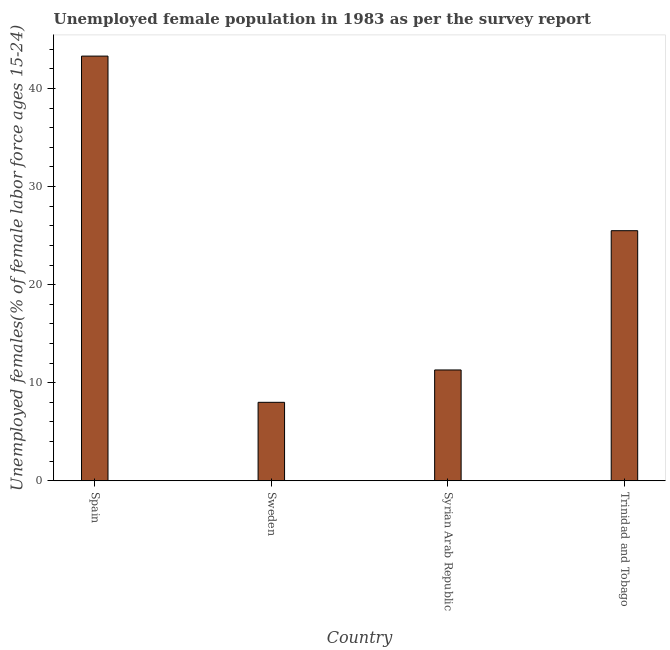What is the title of the graph?
Offer a very short reply. Unemployed female population in 1983 as per the survey report. What is the label or title of the X-axis?
Your answer should be compact. Country. What is the label or title of the Y-axis?
Keep it short and to the point. Unemployed females(% of female labor force ages 15-24). Across all countries, what is the maximum unemployed female youth?
Your answer should be very brief. 43.3. Across all countries, what is the minimum unemployed female youth?
Ensure brevity in your answer.  8. In which country was the unemployed female youth minimum?
Ensure brevity in your answer.  Sweden. What is the sum of the unemployed female youth?
Offer a terse response. 88.1. What is the difference between the unemployed female youth in Syrian Arab Republic and Trinidad and Tobago?
Offer a very short reply. -14.2. What is the average unemployed female youth per country?
Your answer should be very brief. 22.02. What is the median unemployed female youth?
Your response must be concise. 18.4. What is the ratio of the unemployed female youth in Sweden to that in Trinidad and Tobago?
Give a very brief answer. 0.31. Is the difference between the unemployed female youth in Syrian Arab Republic and Trinidad and Tobago greater than the difference between any two countries?
Give a very brief answer. No. What is the difference between the highest and the second highest unemployed female youth?
Ensure brevity in your answer.  17.8. Is the sum of the unemployed female youth in Syrian Arab Republic and Trinidad and Tobago greater than the maximum unemployed female youth across all countries?
Your answer should be compact. No. What is the difference between the highest and the lowest unemployed female youth?
Make the answer very short. 35.3. Are all the bars in the graph horizontal?
Your response must be concise. No. How many countries are there in the graph?
Keep it short and to the point. 4. What is the Unemployed females(% of female labor force ages 15-24) of Spain?
Keep it short and to the point. 43.3. What is the Unemployed females(% of female labor force ages 15-24) of Syrian Arab Republic?
Provide a succinct answer. 11.3. What is the difference between the Unemployed females(% of female labor force ages 15-24) in Spain and Sweden?
Provide a short and direct response. 35.3. What is the difference between the Unemployed females(% of female labor force ages 15-24) in Spain and Syrian Arab Republic?
Your answer should be very brief. 32. What is the difference between the Unemployed females(% of female labor force ages 15-24) in Sweden and Trinidad and Tobago?
Offer a terse response. -17.5. What is the difference between the Unemployed females(% of female labor force ages 15-24) in Syrian Arab Republic and Trinidad and Tobago?
Offer a terse response. -14.2. What is the ratio of the Unemployed females(% of female labor force ages 15-24) in Spain to that in Sweden?
Your answer should be very brief. 5.41. What is the ratio of the Unemployed females(% of female labor force ages 15-24) in Spain to that in Syrian Arab Republic?
Offer a terse response. 3.83. What is the ratio of the Unemployed females(% of female labor force ages 15-24) in Spain to that in Trinidad and Tobago?
Your response must be concise. 1.7. What is the ratio of the Unemployed females(% of female labor force ages 15-24) in Sweden to that in Syrian Arab Republic?
Your response must be concise. 0.71. What is the ratio of the Unemployed females(% of female labor force ages 15-24) in Sweden to that in Trinidad and Tobago?
Offer a very short reply. 0.31. What is the ratio of the Unemployed females(% of female labor force ages 15-24) in Syrian Arab Republic to that in Trinidad and Tobago?
Your answer should be very brief. 0.44. 